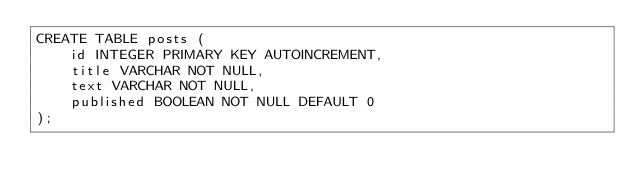Convert code to text. <code><loc_0><loc_0><loc_500><loc_500><_SQL_>CREATE TABLE posts (
    id INTEGER PRIMARY KEY AUTOINCREMENT,
    title VARCHAR NOT NULL,
    text VARCHAR NOT NULL,
    published BOOLEAN NOT NULL DEFAULT 0
);
</code> 